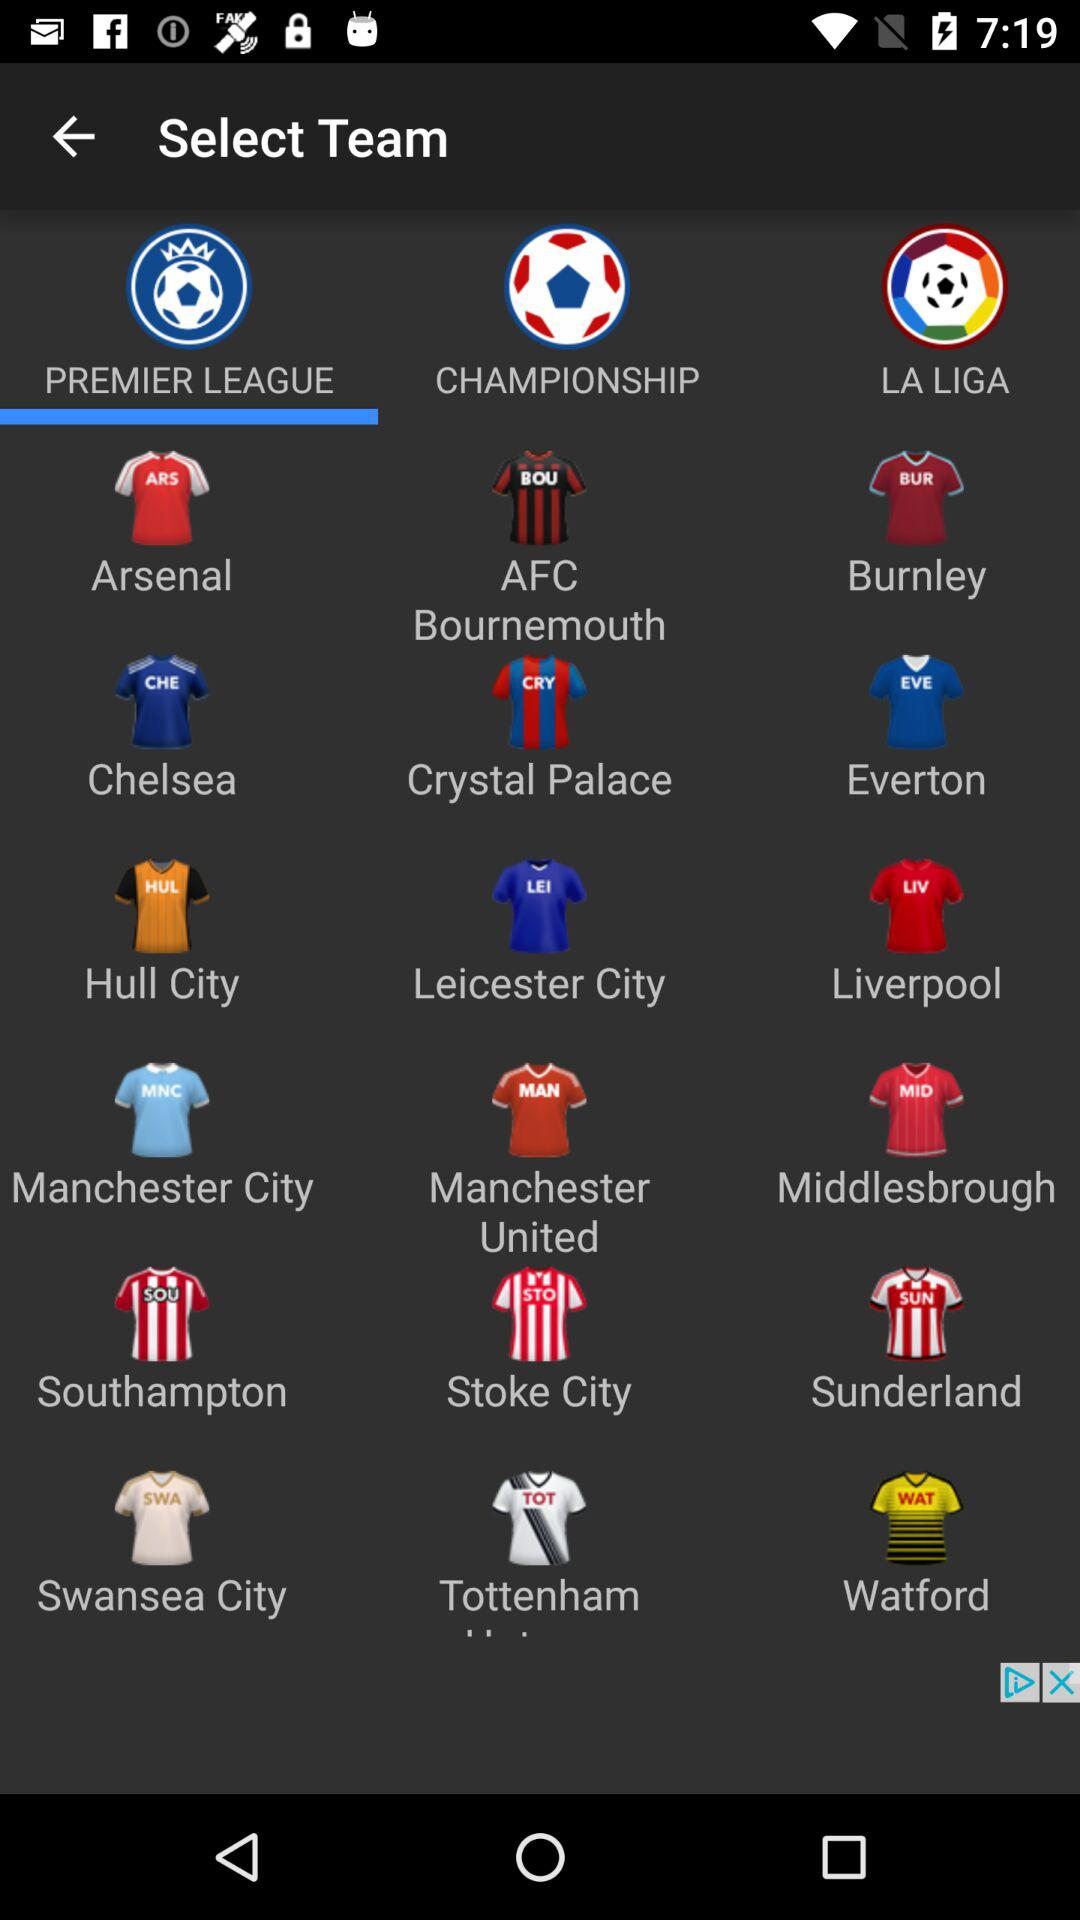Which championship is selected?
When the provided information is insufficient, respond with <no answer>. <no answer> 